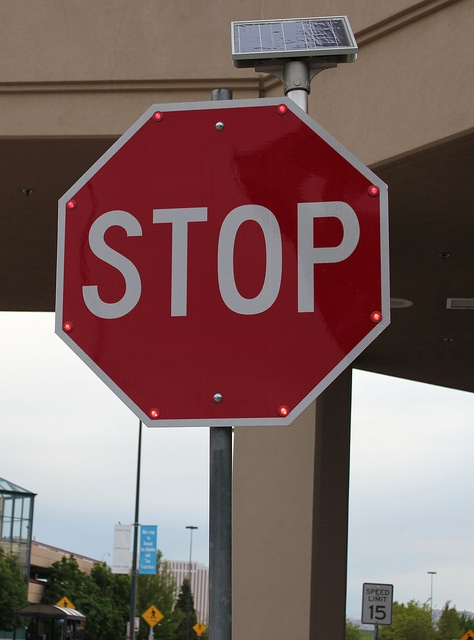Describe the objects in this image and their specific colors. I can see a stop sign in gray and maroon tones in this image. 